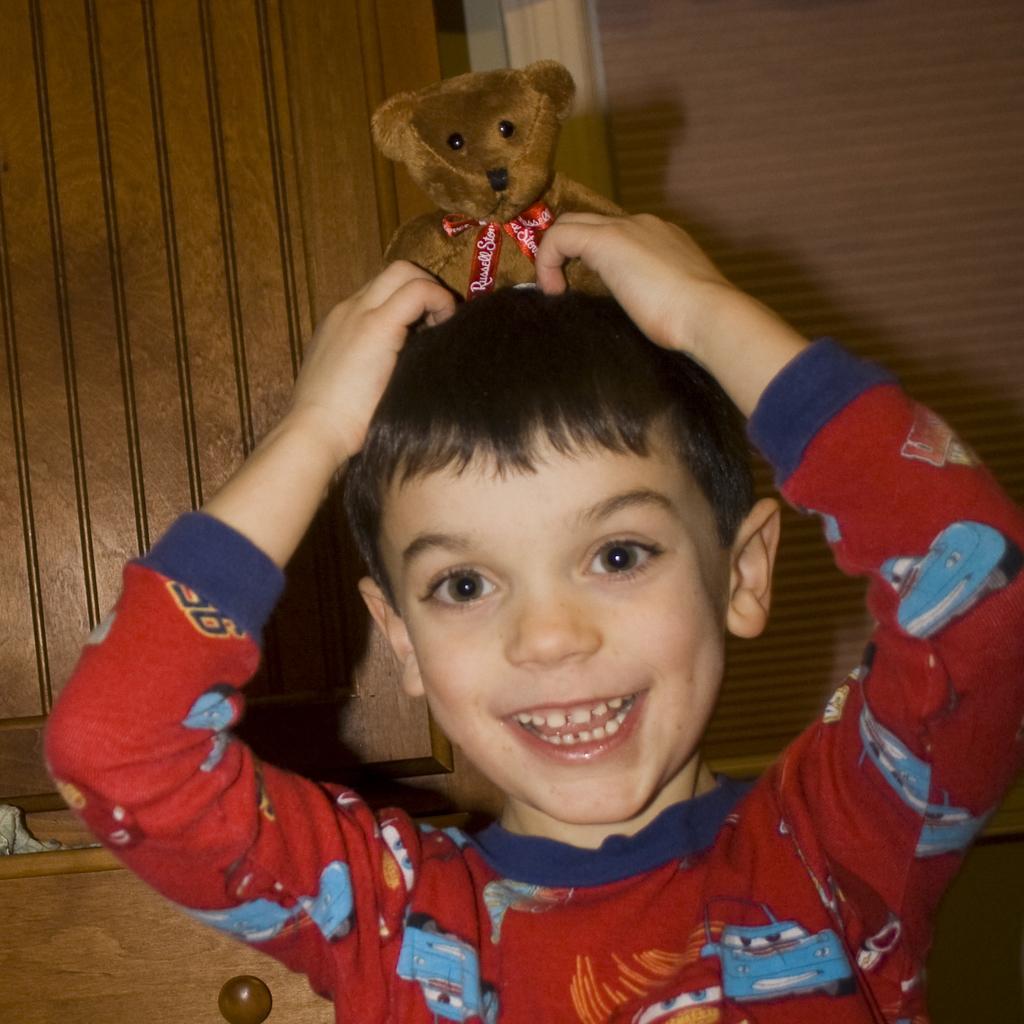How would you summarize this image in a sentence or two? In this image I can see the person holding the toy which is in brown color. The person is wearing the colorful t-shirt. In the back I can see the brown color door and the window blind. 